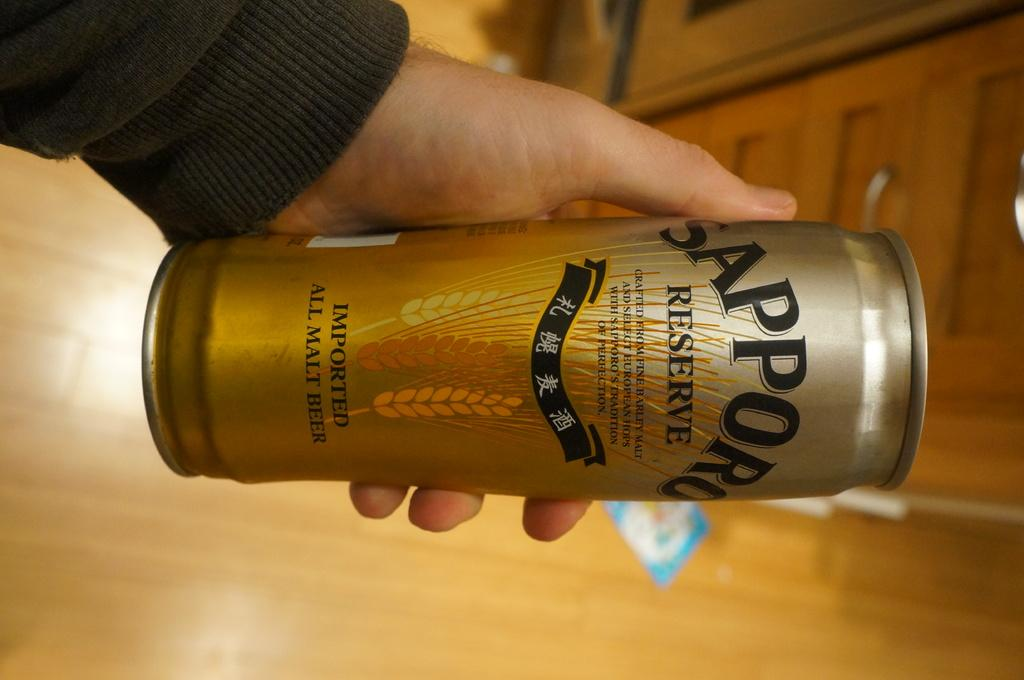Provide a one-sentence caption for the provided image. Someone holds a can of Sapporo Reserve sideways. 